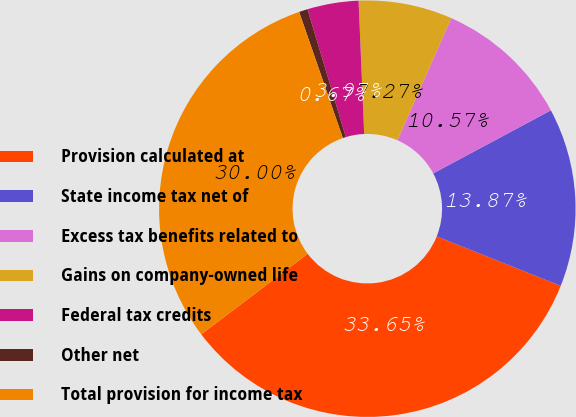Convert chart to OTSL. <chart><loc_0><loc_0><loc_500><loc_500><pie_chart><fcel>Provision calculated at<fcel>State income tax net of<fcel>Excess tax benefits related to<fcel>Gains on company-owned life<fcel>Federal tax credits<fcel>Other net<fcel>Total provision for income tax<nl><fcel>33.65%<fcel>13.87%<fcel>10.57%<fcel>7.27%<fcel>3.97%<fcel>0.67%<fcel>30.0%<nl></chart> 